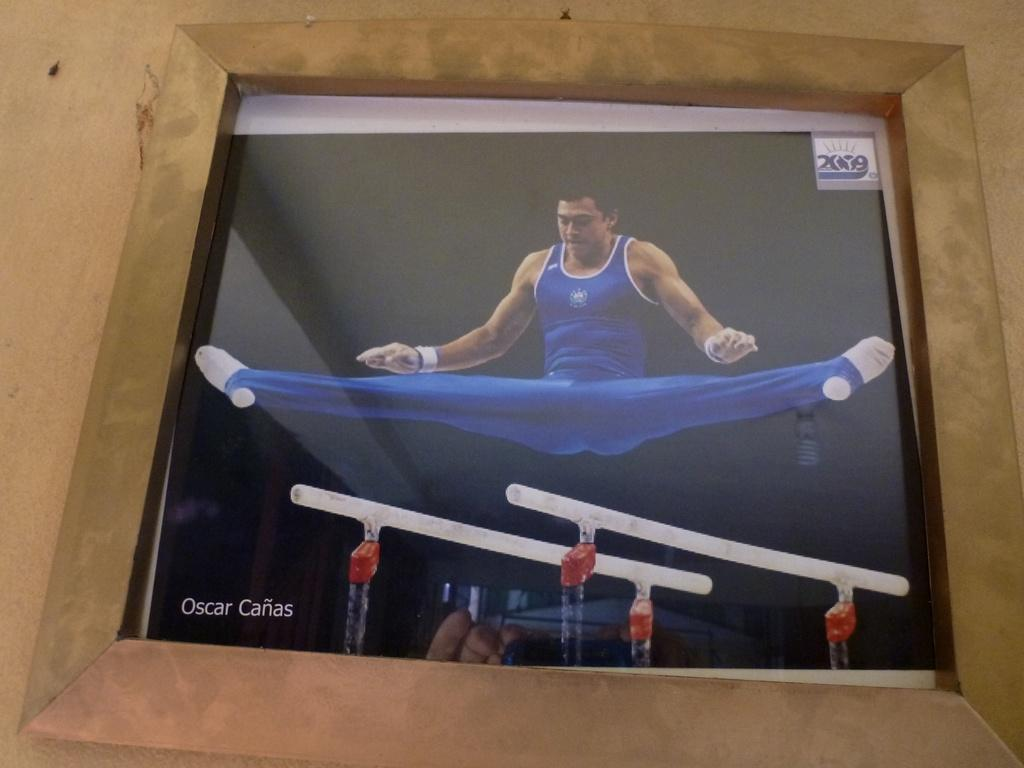<image>
Give a short and clear explanation of the subsequent image. The gymnast, Oscar Canas, demonstrates his flexibility on the even bars. 